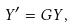<formula> <loc_0><loc_0><loc_500><loc_500>Y ^ { \prime } = G Y ,</formula> 